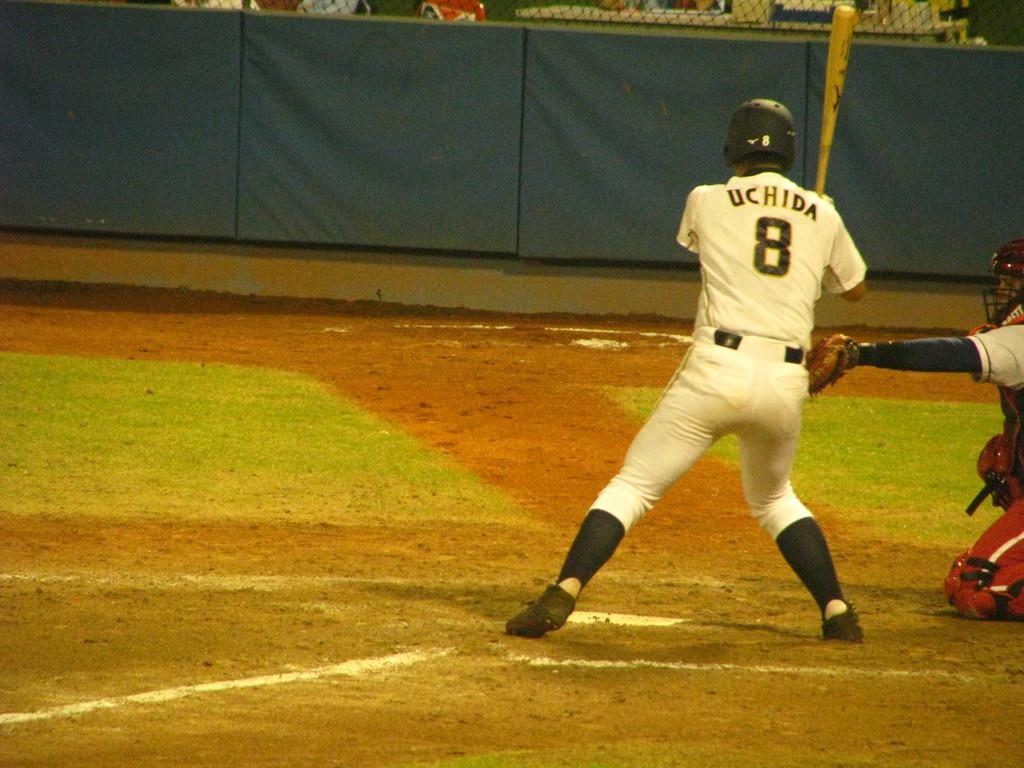<image>
Give a short and clear explanation of the subsequent image. a person with UCHIDA 8 on their jersey is at bat 